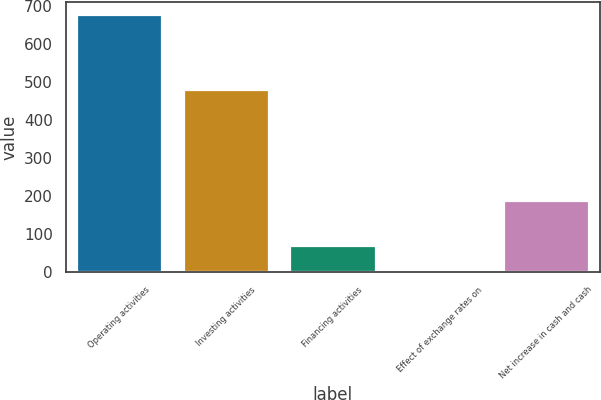Convert chart. <chart><loc_0><loc_0><loc_500><loc_500><bar_chart><fcel>Operating activities<fcel>Investing activities<fcel>Financing activities<fcel>Effect of exchange rates on<fcel>Net increase in cash and cash<nl><fcel>677.6<fcel>479<fcel>67.94<fcel>0.2<fcel>186<nl></chart> 